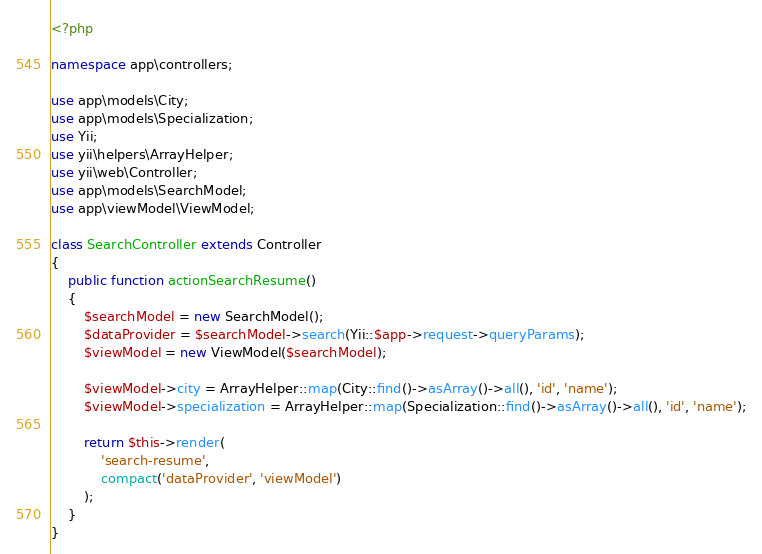<code> <loc_0><loc_0><loc_500><loc_500><_PHP_><?php

namespace app\controllers;

use app\models\City;
use app\models\Specialization;
use Yii;
use yii\helpers\ArrayHelper;
use yii\web\Controller;
use app\models\SearchModel;
use app\viewModel\ViewModel;

class SearchController extends Controller
{
    public function actionSearchResume()
    {
        $searchModel = new SearchModel();
        $dataProvider = $searchModel->search(Yii::$app->request->queryParams);
        $viewModel = new ViewModel($searchModel);

        $viewModel->city = ArrayHelper::map(City::find()->asArray()->all(), 'id', 'name');
        $viewModel->specialization = ArrayHelper::map(Specialization::find()->asArray()->all(), 'id', 'name');

        return $this->render(
            'search-resume',
            compact('dataProvider', 'viewModel')
        );
    }
}</code> 